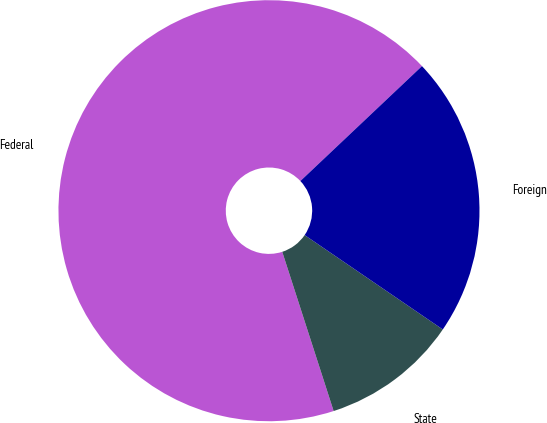Convert chart to OTSL. <chart><loc_0><loc_0><loc_500><loc_500><pie_chart><fcel>Federal<fcel>State<fcel>Foreign<nl><fcel>67.92%<fcel>10.49%<fcel>21.59%<nl></chart> 